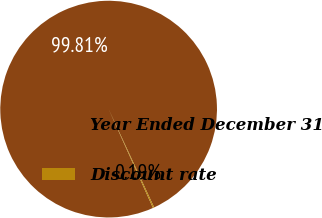<chart> <loc_0><loc_0><loc_500><loc_500><pie_chart><fcel>Year Ended December 31<fcel>Discount rate<nl><fcel>99.81%<fcel>0.19%<nl></chart> 